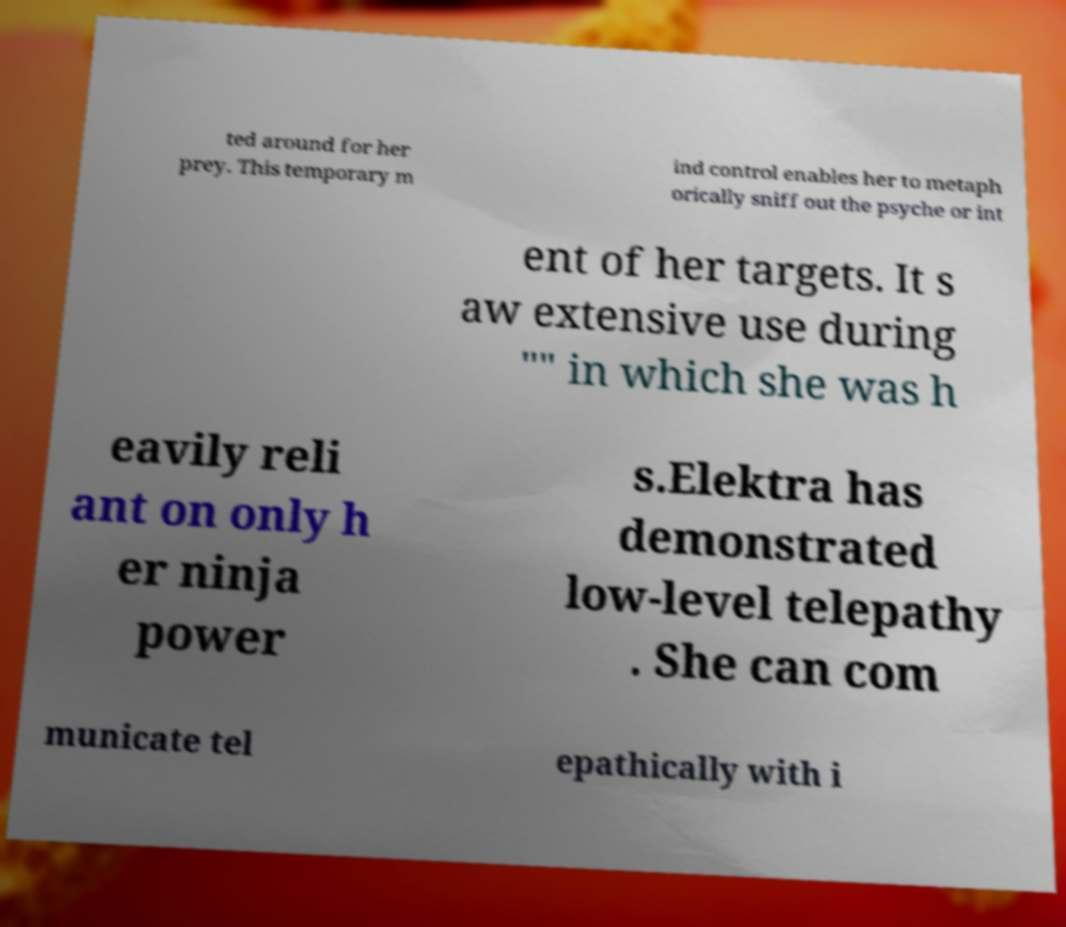Can you read and provide the text displayed in the image?This photo seems to have some interesting text. Can you extract and type it out for me? ted around for her prey. This temporary m ind control enables her to metaph orically sniff out the psyche or int ent of her targets. It s aw extensive use during "" in which she was h eavily reli ant on only h er ninja power s.Elektra has demonstrated low-level telepathy . She can com municate tel epathically with i 